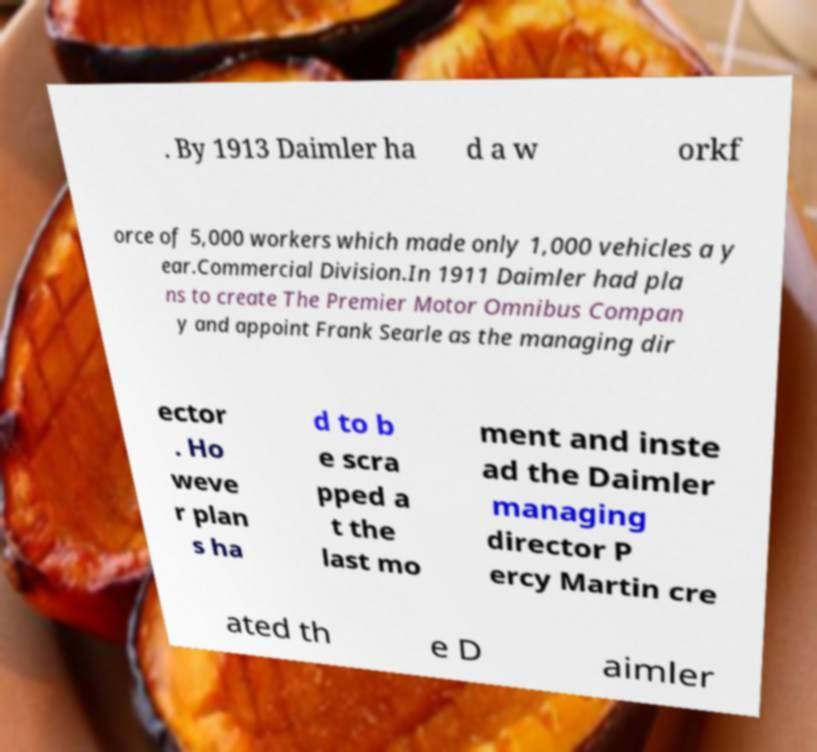There's text embedded in this image that I need extracted. Can you transcribe it verbatim? . By 1913 Daimler ha d a w orkf orce of 5,000 workers which made only 1,000 vehicles a y ear.Commercial Division.In 1911 Daimler had pla ns to create The Premier Motor Omnibus Compan y and appoint Frank Searle as the managing dir ector . Ho weve r plan s ha d to b e scra pped a t the last mo ment and inste ad the Daimler managing director P ercy Martin cre ated th e D aimler 